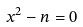Convert formula to latex. <formula><loc_0><loc_0><loc_500><loc_500>x ^ { 2 } - n = 0</formula> 